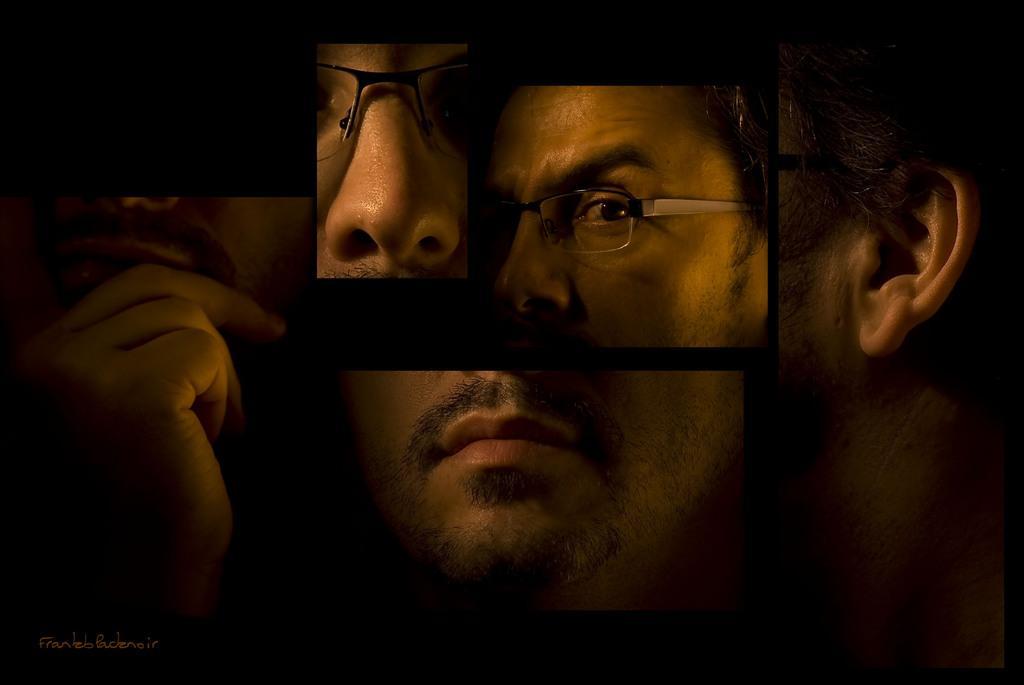How would you summarize this image in a sentence or two? In this image we can see the collage picture of a man. 